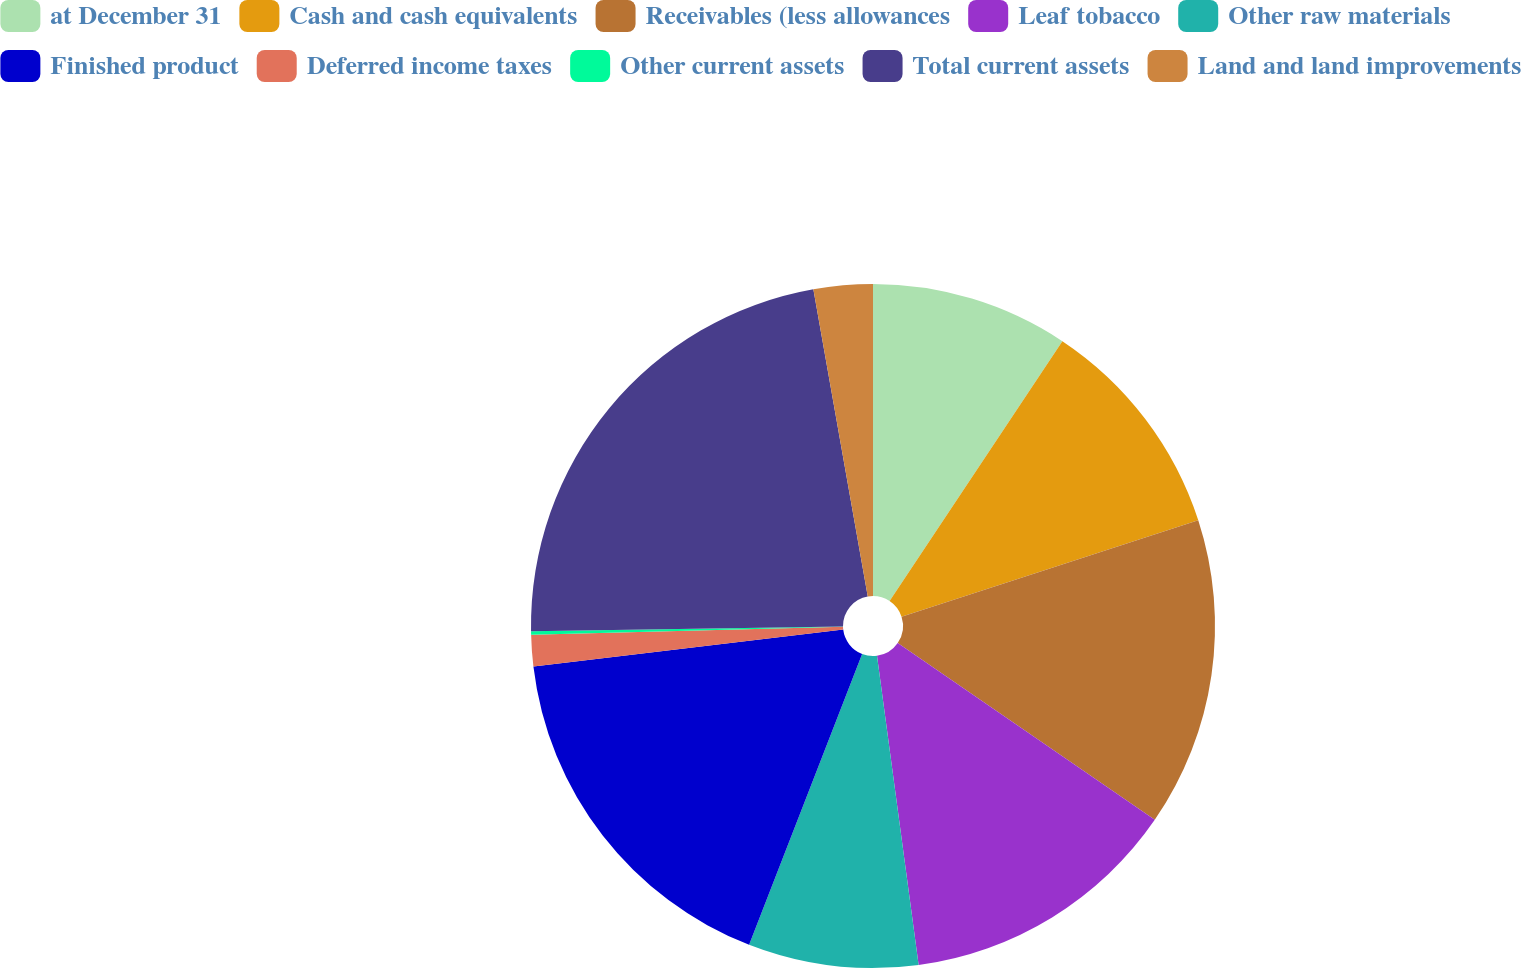<chart> <loc_0><loc_0><loc_500><loc_500><pie_chart><fcel>at December 31<fcel>Cash and cash equivalents<fcel>Receivables (less allowances<fcel>Leaf tobacco<fcel>Other raw materials<fcel>Finished product<fcel>Deferred income taxes<fcel>Other current assets<fcel>Total current assets<fcel>Land and land improvements<nl><fcel>9.34%<fcel>10.66%<fcel>14.59%<fcel>13.28%<fcel>8.03%<fcel>17.21%<fcel>1.48%<fcel>0.17%<fcel>22.45%<fcel>2.79%<nl></chart> 